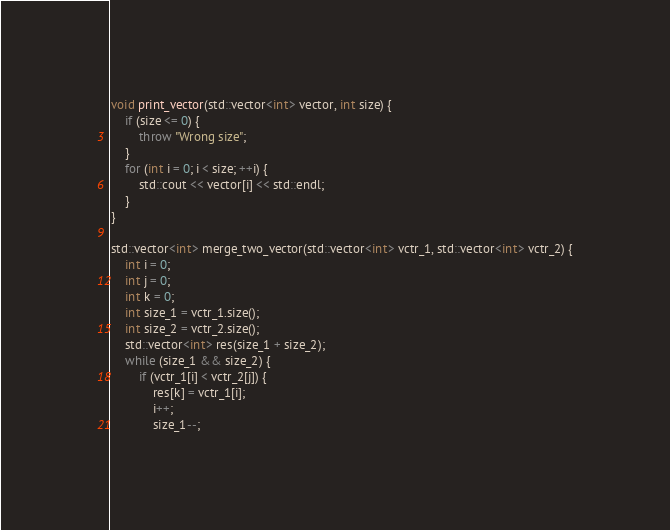Convert code to text. <code><loc_0><loc_0><loc_500><loc_500><_C++_>void print_vector(std::vector<int> vector, int size) {
    if (size <= 0) {
        throw "Wrong size";
    }
    for (int i = 0; i < size; ++i) {
        std::cout << vector[i] << std::endl;
    }
}

std::vector<int> merge_two_vector(std::vector<int> vctr_1, std::vector<int> vctr_2) {
    int i = 0;
    int j = 0;
    int k = 0;
    int size_1 = vctr_1.size();
    int size_2 = vctr_2.size();
    std::vector<int> res(size_1 + size_2);
    while (size_1 && size_2) {
        if (vctr_1[i] < vctr_2[j]) {
            res[k] = vctr_1[i];
            i++;
            size_1--;</code> 